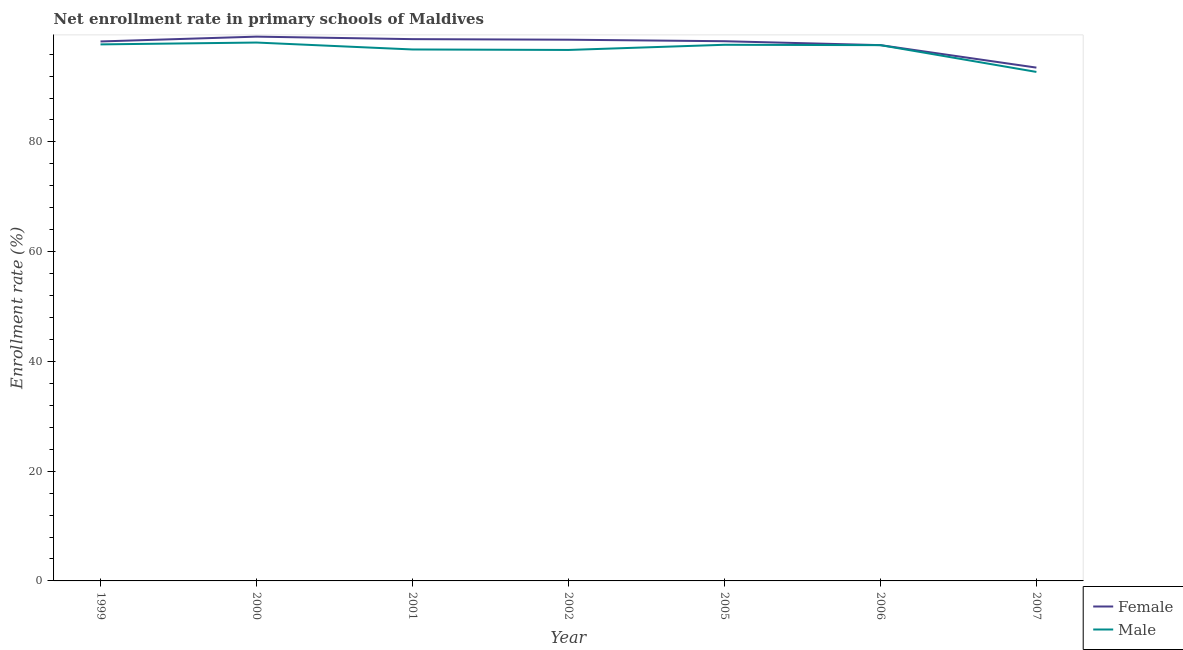Is the number of lines equal to the number of legend labels?
Give a very brief answer. Yes. What is the enrollment rate of male students in 2005?
Ensure brevity in your answer.  97.71. Across all years, what is the maximum enrollment rate of male students?
Make the answer very short. 98.12. Across all years, what is the minimum enrollment rate of female students?
Offer a very short reply. 93.55. What is the total enrollment rate of male students in the graph?
Keep it short and to the point. 677.61. What is the difference between the enrollment rate of male students in 2005 and that in 2006?
Your response must be concise. 0.07. What is the difference between the enrollment rate of male students in 2005 and the enrollment rate of female students in 1999?
Provide a short and direct response. -0.61. What is the average enrollment rate of female students per year?
Offer a very short reply. 97.77. In the year 1999, what is the difference between the enrollment rate of female students and enrollment rate of male students?
Offer a terse response. 0.53. In how many years, is the enrollment rate of male students greater than 24 %?
Keep it short and to the point. 7. What is the ratio of the enrollment rate of male students in 1999 to that in 2000?
Your response must be concise. 1. What is the difference between the highest and the second highest enrollment rate of male students?
Your response must be concise. 0.34. What is the difference between the highest and the lowest enrollment rate of female students?
Make the answer very short. 5.64. In how many years, is the enrollment rate of male students greater than the average enrollment rate of male students taken over all years?
Provide a short and direct response. 5. Is the sum of the enrollment rate of female students in 2000 and 2005 greater than the maximum enrollment rate of male students across all years?
Give a very brief answer. Yes. Does the enrollment rate of male students monotonically increase over the years?
Your response must be concise. No. How many years are there in the graph?
Your answer should be compact. 7. What is the difference between two consecutive major ticks on the Y-axis?
Give a very brief answer. 20. Are the values on the major ticks of Y-axis written in scientific E-notation?
Offer a very short reply. No. Does the graph contain any zero values?
Ensure brevity in your answer.  No. Does the graph contain grids?
Make the answer very short. No. Where does the legend appear in the graph?
Your answer should be compact. Bottom right. What is the title of the graph?
Offer a terse response. Net enrollment rate in primary schools of Maldives. What is the label or title of the Y-axis?
Ensure brevity in your answer.  Enrollment rate (%). What is the Enrollment rate (%) in Female in 1999?
Ensure brevity in your answer.  98.31. What is the Enrollment rate (%) in Male in 1999?
Offer a terse response. 97.78. What is the Enrollment rate (%) of Female in 2000?
Keep it short and to the point. 99.19. What is the Enrollment rate (%) in Male in 2000?
Offer a terse response. 98.12. What is the Enrollment rate (%) of Female in 2001?
Your response must be concise. 98.73. What is the Enrollment rate (%) of Male in 2001?
Your response must be concise. 96.85. What is the Enrollment rate (%) of Female in 2002?
Your answer should be very brief. 98.63. What is the Enrollment rate (%) of Male in 2002?
Your answer should be compact. 96.76. What is the Enrollment rate (%) of Female in 2005?
Your answer should be compact. 98.36. What is the Enrollment rate (%) in Male in 2005?
Provide a short and direct response. 97.71. What is the Enrollment rate (%) in Female in 2006?
Your response must be concise. 97.64. What is the Enrollment rate (%) in Male in 2006?
Offer a very short reply. 97.64. What is the Enrollment rate (%) in Female in 2007?
Make the answer very short. 93.55. What is the Enrollment rate (%) of Male in 2007?
Give a very brief answer. 92.76. Across all years, what is the maximum Enrollment rate (%) in Female?
Make the answer very short. 99.19. Across all years, what is the maximum Enrollment rate (%) of Male?
Provide a short and direct response. 98.12. Across all years, what is the minimum Enrollment rate (%) of Female?
Your response must be concise. 93.55. Across all years, what is the minimum Enrollment rate (%) of Male?
Keep it short and to the point. 92.76. What is the total Enrollment rate (%) in Female in the graph?
Your answer should be very brief. 684.41. What is the total Enrollment rate (%) in Male in the graph?
Your response must be concise. 677.61. What is the difference between the Enrollment rate (%) of Female in 1999 and that in 2000?
Offer a very short reply. -0.88. What is the difference between the Enrollment rate (%) in Male in 1999 and that in 2000?
Make the answer very short. -0.34. What is the difference between the Enrollment rate (%) in Female in 1999 and that in 2001?
Your answer should be very brief. -0.42. What is the difference between the Enrollment rate (%) in Male in 1999 and that in 2001?
Keep it short and to the point. 0.93. What is the difference between the Enrollment rate (%) in Female in 1999 and that in 2002?
Offer a very short reply. -0.32. What is the difference between the Enrollment rate (%) of Male in 1999 and that in 2002?
Give a very brief answer. 1.01. What is the difference between the Enrollment rate (%) in Female in 1999 and that in 2005?
Provide a succinct answer. -0.04. What is the difference between the Enrollment rate (%) of Male in 1999 and that in 2005?
Make the answer very short. 0.07. What is the difference between the Enrollment rate (%) of Female in 1999 and that in 2006?
Give a very brief answer. 0.67. What is the difference between the Enrollment rate (%) of Male in 1999 and that in 2006?
Your answer should be compact. 0.14. What is the difference between the Enrollment rate (%) in Female in 1999 and that in 2007?
Your answer should be compact. 4.77. What is the difference between the Enrollment rate (%) of Male in 1999 and that in 2007?
Make the answer very short. 5.02. What is the difference between the Enrollment rate (%) in Female in 2000 and that in 2001?
Give a very brief answer. 0.46. What is the difference between the Enrollment rate (%) of Male in 2000 and that in 2001?
Give a very brief answer. 1.26. What is the difference between the Enrollment rate (%) of Female in 2000 and that in 2002?
Keep it short and to the point. 0.56. What is the difference between the Enrollment rate (%) of Male in 2000 and that in 2002?
Give a very brief answer. 1.35. What is the difference between the Enrollment rate (%) of Female in 2000 and that in 2005?
Provide a short and direct response. 0.83. What is the difference between the Enrollment rate (%) of Male in 2000 and that in 2005?
Offer a very short reply. 0.41. What is the difference between the Enrollment rate (%) in Female in 2000 and that in 2006?
Offer a terse response. 1.55. What is the difference between the Enrollment rate (%) in Male in 2000 and that in 2006?
Keep it short and to the point. 0.48. What is the difference between the Enrollment rate (%) of Female in 2000 and that in 2007?
Give a very brief answer. 5.64. What is the difference between the Enrollment rate (%) of Male in 2000 and that in 2007?
Your answer should be very brief. 5.36. What is the difference between the Enrollment rate (%) in Female in 2001 and that in 2002?
Keep it short and to the point. 0.1. What is the difference between the Enrollment rate (%) of Male in 2001 and that in 2002?
Provide a succinct answer. 0.09. What is the difference between the Enrollment rate (%) in Female in 2001 and that in 2005?
Offer a terse response. 0.38. What is the difference between the Enrollment rate (%) of Male in 2001 and that in 2005?
Your answer should be compact. -0.85. What is the difference between the Enrollment rate (%) in Female in 2001 and that in 2006?
Your response must be concise. 1.09. What is the difference between the Enrollment rate (%) in Male in 2001 and that in 2006?
Offer a terse response. -0.79. What is the difference between the Enrollment rate (%) of Female in 2001 and that in 2007?
Your response must be concise. 5.19. What is the difference between the Enrollment rate (%) of Male in 2001 and that in 2007?
Offer a very short reply. 4.09. What is the difference between the Enrollment rate (%) of Female in 2002 and that in 2005?
Your response must be concise. 0.27. What is the difference between the Enrollment rate (%) in Male in 2002 and that in 2005?
Provide a short and direct response. -0.94. What is the difference between the Enrollment rate (%) in Male in 2002 and that in 2006?
Your answer should be compact. -0.87. What is the difference between the Enrollment rate (%) in Female in 2002 and that in 2007?
Offer a terse response. 5.09. What is the difference between the Enrollment rate (%) in Male in 2002 and that in 2007?
Give a very brief answer. 4. What is the difference between the Enrollment rate (%) of Female in 2005 and that in 2006?
Give a very brief answer. 0.71. What is the difference between the Enrollment rate (%) in Male in 2005 and that in 2006?
Provide a short and direct response. 0.07. What is the difference between the Enrollment rate (%) of Female in 2005 and that in 2007?
Your answer should be compact. 4.81. What is the difference between the Enrollment rate (%) of Male in 2005 and that in 2007?
Give a very brief answer. 4.95. What is the difference between the Enrollment rate (%) of Female in 2006 and that in 2007?
Offer a very short reply. 4.1. What is the difference between the Enrollment rate (%) of Male in 2006 and that in 2007?
Ensure brevity in your answer.  4.88. What is the difference between the Enrollment rate (%) in Female in 1999 and the Enrollment rate (%) in Male in 2000?
Offer a terse response. 0.2. What is the difference between the Enrollment rate (%) of Female in 1999 and the Enrollment rate (%) of Male in 2001?
Provide a succinct answer. 1.46. What is the difference between the Enrollment rate (%) in Female in 1999 and the Enrollment rate (%) in Male in 2002?
Make the answer very short. 1.55. What is the difference between the Enrollment rate (%) of Female in 1999 and the Enrollment rate (%) of Male in 2005?
Offer a terse response. 0.61. What is the difference between the Enrollment rate (%) of Female in 1999 and the Enrollment rate (%) of Male in 2006?
Keep it short and to the point. 0.67. What is the difference between the Enrollment rate (%) in Female in 1999 and the Enrollment rate (%) in Male in 2007?
Provide a succinct answer. 5.55. What is the difference between the Enrollment rate (%) in Female in 2000 and the Enrollment rate (%) in Male in 2001?
Give a very brief answer. 2.34. What is the difference between the Enrollment rate (%) of Female in 2000 and the Enrollment rate (%) of Male in 2002?
Give a very brief answer. 2.43. What is the difference between the Enrollment rate (%) in Female in 2000 and the Enrollment rate (%) in Male in 2005?
Keep it short and to the point. 1.48. What is the difference between the Enrollment rate (%) in Female in 2000 and the Enrollment rate (%) in Male in 2006?
Your answer should be compact. 1.55. What is the difference between the Enrollment rate (%) of Female in 2000 and the Enrollment rate (%) of Male in 2007?
Offer a very short reply. 6.43. What is the difference between the Enrollment rate (%) in Female in 2001 and the Enrollment rate (%) in Male in 2002?
Provide a short and direct response. 1.97. What is the difference between the Enrollment rate (%) in Female in 2001 and the Enrollment rate (%) in Male in 2005?
Your response must be concise. 1.03. What is the difference between the Enrollment rate (%) of Female in 2001 and the Enrollment rate (%) of Male in 2006?
Offer a terse response. 1.1. What is the difference between the Enrollment rate (%) in Female in 2001 and the Enrollment rate (%) in Male in 2007?
Your response must be concise. 5.97. What is the difference between the Enrollment rate (%) of Female in 2002 and the Enrollment rate (%) of Male in 2005?
Your response must be concise. 0.92. What is the difference between the Enrollment rate (%) in Female in 2002 and the Enrollment rate (%) in Male in 2006?
Provide a short and direct response. 0.99. What is the difference between the Enrollment rate (%) of Female in 2002 and the Enrollment rate (%) of Male in 2007?
Your answer should be very brief. 5.87. What is the difference between the Enrollment rate (%) of Female in 2005 and the Enrollment rate (%) of Male in 2006?
Your answer should be very brief. 0.72. What is the difference between the Enrollment rate (%) of Female in 2005 and the Enrollment rate (%) of Male in 2007?
Ensure brevity in your answer.  5.6. What is the difference between the Enrollment rate (%) in Female in 2006 and the Enrollment rate (%) in Male in 2007?
Give a very brief answer. 4.88. What is the average Enrollment rate (%) in Female per year?
Provide a short and direct response. 97.77. What is the average Enrollment rate (%) of Male per year?
Your response must be concise. 96.8. In the year 1999, what is the difference between the Enrollment rate (%) of Female and Enrollment rate (%) of Male?
Make the answer very short. 0.53. In the year 2000, what is the difference between the Enrollment rate (%) in Female and Enrollment rate (%) in Male?
Provide a short and direct response. 1.08. In the year 2001, what is the difference between the Enrollment rate (%) of Female and Enrollment rate (%) of Male?
Provide a succinct answer. 1.88. In the year 2002, what is the difference between the Enrollment rate (%) of Female and Enrollment rate (%) of Male?
Provide a succinct answer. 1.87. In the year 2005, what is the difference between the Enrollment rate (%) of Female and Enrollment rate (%) of Male?
Make the answer very short. 0.65. In the year 2006, what is the difference between the Enrollment rate (%) in Female and Enrollment rate (%) in Male?
Provide a short and direct response. 0. In the year 2007, what is the difference between the Enrollment rate (%) of Female and Enrollment rate (%) of Male?
Offer a very short reply. 0.79. What is the ratio of the Enrollment rate (%) in Male in 1999 to that in 2001?
Provide a succinct answer. 1.01. What is the ratio of the Enrollment rate (%) of Male in 1999 to that in 2002?
Provide a succinct answer. 1.01. What is the ratio of the Enrollment rate (%) of Male in 1999 to that in 2006?
Your answer should be compact. 1. What is the ratio of the Enrollment rate (%) in Female in 1999 to that in 2007?
Ensure brevity in your answer.  1.05. What is the ratio of the Enrollment rate (%) of Male in 1999 to that in 2007?
Your answer should be compact. 1.05. What is the ratio of the Enrollment rate (%) of Female in 2000 to that in 2001?
Offer a terse response. 1. What is the ratio of the Enrollment rate (%) of Female in 2000 to that in 2002?
Provide a short and direct response. 1.01. What is the ratio of the Enrollment rate (%) in Male in 2000 to that in 2002?
Ensure brevity in your answer.  1.01. What is the ratio of the Enrollment rate (%) in Female in 2000 to that in 2005?
Make the answer very short. 1.01. What is the ratio of the Enrollment rate (%) in Male in 2000 to that in 2005?
Offer a very short reply. 1. What is the ratio of the Enrollment rate (%) of Female in 2000 to that in 2006?
Make the answer very short. 1.02. What is the ratio of the Enrollment rate (%) of Female in 2000 to that in 2007?
Your answer should be compact. 1.06. What is the ratio of the Enrollment rate (%) in Male in 2000 to that in 2007?
Provide a succinct answer. 1.06. What is the ratio of the Enrollment rate (%) of Female in 2001 to that in 2005?
Make the answer very short. 1. What is the ratio of the Enrollment rate (%) of Female in 2001 to that in 2006?
Your answer should be very brief. 1.01. What is the ratio of the Enrollment rate (%) in Male in 2001 to that in 2006?
Offer a terse response. 0.99. What is the ratio of the Enrollment rate (%) in Female in 2001 to that in 2007?
Offer a very short reply. 1.06. What is the ratio of the Enrollment rate (%) of Male in 2001 to that in 2007?
Offer a very short reply. 1.04. What is the ratio of the Enrollment rate (%) in Male in 2002 to that in 2005?
Ensure brevity in your answer.  0.99. What is the ratio of the Enrollment rate (%) in Female in 2002 to that in 2006?
Your answer should be very brief. 1.01. What is the ratio of the Enrollment rate (%) in Female in 2002 to that in 2007?
Make the answer very short. 1.05. What is the ratio of the Enrollment rate (%) of Male in 2002 to that in 2007?
Your response must be concise. 1.04. What is the ratio of the Enrollment rate (%) of Female in 2005 to that in 2006?
Give a very brief answer. 1.01. What is the ratio of the Enrollment rate (%) in Male in 2005 to that in 2006?
Offer a very short reply. 1. What is the ratio of the Enrollment rate (%) of Female in 2005 to that in 2007?
Make the answer very short. 1.05. What is the ratio of the Enrollment rate (%) of Male in 2005 to that in 2007?
Offer a terse response. 1.05. What is the ratio of the Enrollment rate (%) in Female in 2006 to that in 2007?
Keep it short and to the point. 1.04. What is the ratio of the Enrollment rate (%) of Male in 2006 to that in 2007?
Provide a succinct answer. 1.05. What is the difference between the highest and the second highest Enrollment rate (%) of Female?
Keep it short and to the point. 0.46. What is the difference between the highest and the second highest Enrollment rate (%) in Male?
Keep it short and to the point. 0.34. What is the difference between the highest and the lowest Enrollment rate (%) in Female?
Provide a succinct answer. 5.64. What is the difference between the highest and the lowest Enrollment rate (%) in Male?
Provide a short and direct response. 5.36. 